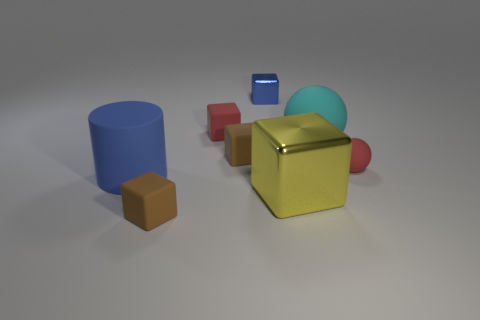There is a small block that is the same color as the cylinder; what is its material?
Your answer should be compact. Metal. Does the small rubber sphere have the same color as the tiny rubber cube behind the big ball?
Provide a short and direct response. Yes. What material is the cylinder that is the same size as the cyan ball?
Give a very brief answer. Rubber. What material is the big cyan thing?
Your answer should be compact. Rubber. Is the shape of the small metal object the same as the red thing that is to the left of the yellow metal thing?
Your response must be concise. Yes. There is another big object that is the same shape as the blue metal object; what is it made of?
Provide a short and direct response. Metal. How many red things have the same shape as the large cyan rubber object?
Keep it short and to the point. 1. What shape is the tiny red thing that is to the right of the big thing behind the red ball?
Provide a short and direct response. Sphere. There is a blue cylinder that is behind the yellow cube; is it the same size as the yellow block?
Give a very brief answer. Yes. How big is the cube that is in front of the red cube and behind the big cylinder?
Your answer should be very brief. Small. 